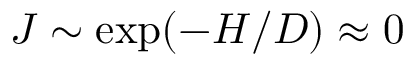Convert formula to latex. <formula><loc_0><loc_0><loc_500><loc_500>J \sim \exp ( - H / D ) \approx 0</formula> 